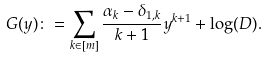Convert formula to latex. <formula><loc_0><loc_0><loc_500><loc_500>G ( y ) \colon = \sum _ { k \in [ m ] } \frac { \alpha _ { k } - \delta _ { 1 , k } } { k + 1 } y ^ { k + 1 } + \log ( D ) .</formula> 